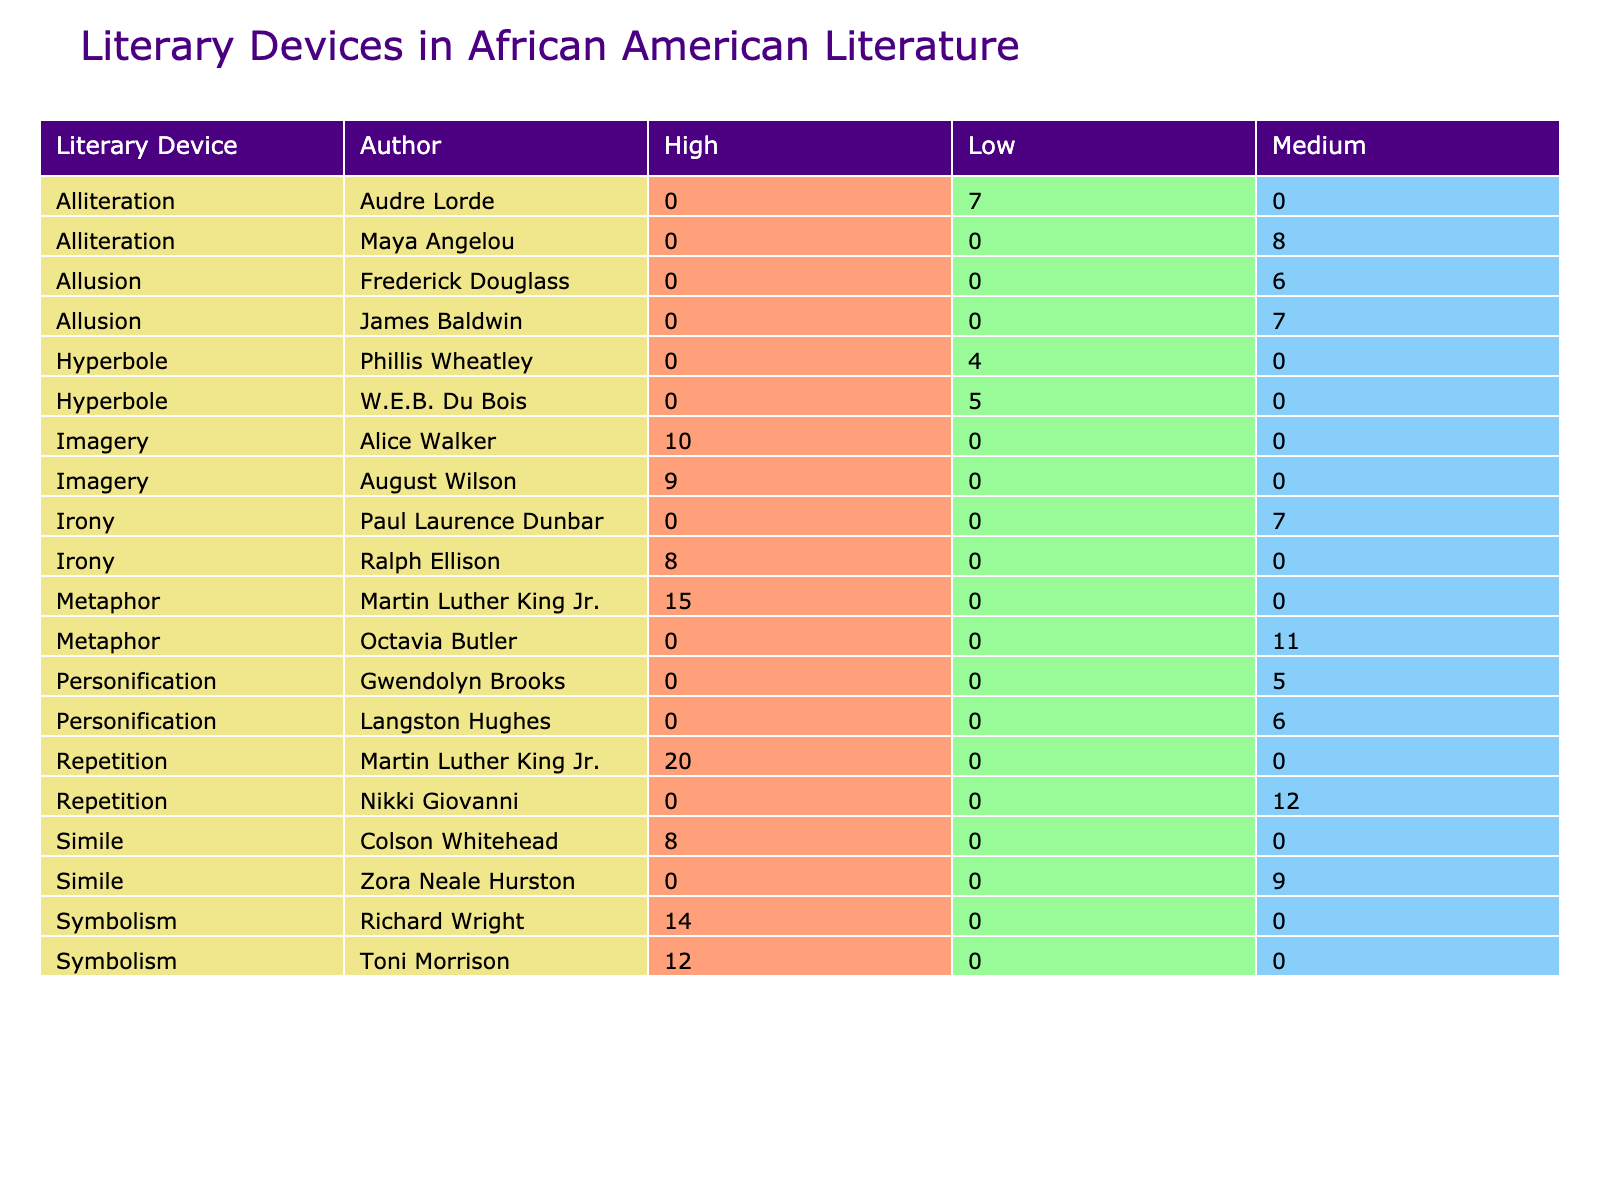What is the frequency of metaphors used by Martin Luther King Jr.? The table indicates that Martin Luther King Jr. used metaphors in "I Have a Dream" 15 times.
Answer: 15 Which literary device has the highest total frequency across all works in the table? By examining the "Frequency" column for each literary device, "Repetition" has the highest total frequency with 20 occurrences in Martin Luther King Jr.'s "Letter from Birmingham Jail."
Answer: Repetition Is symbolism used more frequently than personification in African American literature according to this table? Symbolism appears a total of 26 times (12 from Toni Morrison and 14 from Richard Wright), while personification appears a total of 11 times (6 from Langston Hughes and 5 from Gwendolyn Brooks). Therefore, symbolism is indeed used more frequently.
Answer: Yes How many different works by different authors include personification? The table shows that personification is used in two works: "The Negro Speaks of Rivers" by Langston Hughes and "We Real Cool" by Gwendolyn Brooks.
Answer: 2 Calculate the average frequency of allusion across the authors presented in the table. The frequencies for allusion are 7 from James Baldwin and 6 from Frederick Douglass, which totals to 13. To find the average, divide the total frequency by the number of instances, so 13 divided by 2 equals 6.5.
Answer: 6.5 Which author has the highest use of alliteration, and what is the frequency? By looking through the table for alliteration, Maya Angelou uses it 8 times in "Still I Rise," which is the highest frequency for this device.
Answer: Maya Angelou, 8 Are there any authors who employed hyperbole in their works? Yes, the table indicates that W.E.B. Du Bois used hyperbole in "The Souls of Black Folk" with a frequency of 5, and Phillis Wheatley used it in "On Being Brought from Africa to America" with a frequency of 4.
Answer: Yes What is the combined frequency of similes used in African American literature according to the data? The combined frequency of similes from the table includes 9 from Zora Neale Hurston and 8 from Colson Whitehead, which adds up to a total of 17.
Answer: 17 What is the literary device with the lowest impact according to the table? The table shows that hyperbole has the lowest impact rating as it is recorded as "Low."
Answer: Hyperbole 